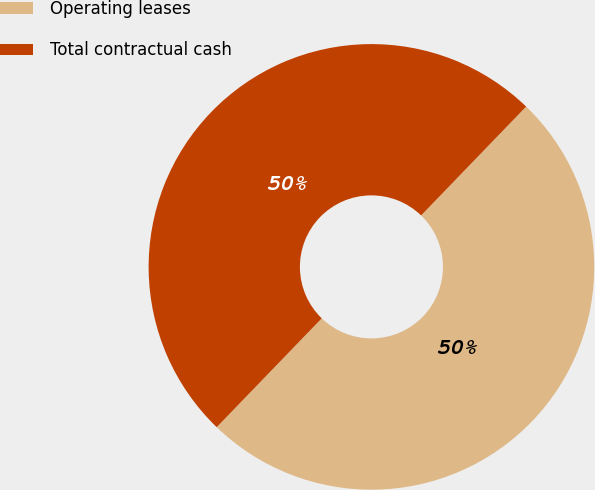Convert chart to OTSL. <chart><loc_0><loc_0><loc_500><loc_500><pie_chart><fcel>Operating leases<fcel>Total contractual cash<nl><fcel>50.0%<fcel>50.0%<nl></chart> 